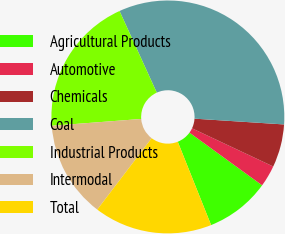<chart> <loc_0><loc_0><loc_500><loc_500><pie_chart><fcel>Agricultural Products<fcel>Automotive<fcel>Chemicals<fcel>Coal<fcel>Industrial Products<fcel>Intermodal<fcel>Total<nl><fcel>8.96%<fcel>2.99%<fcel>5.97%<fcel>32.84%<fcel>19.4%<fcel>13.43%<fcel>16.42%<nl></chart> 